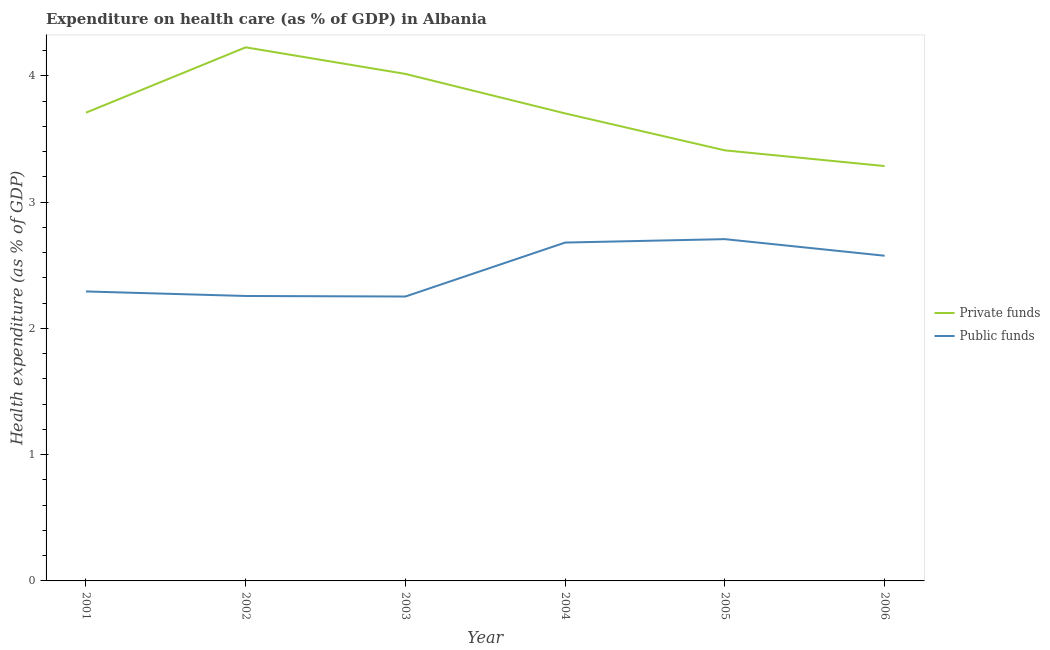How many different coloured lines are there?
Your answer should be very brief. 2. Does the line corresponding to amount of private funds spent in healthcare intersect with the line corresponding to amount of public funds spent in healthcare?
Make the answer very short. No. Is the number of lines equal to the number of legend labels?
Your answer should be very brief. Yes. What is the amount of public funds spent in healthcare in 2004?
Keep it short and to the point. 2.68. Across all years, what is the maximum amount of public funds spent in healthcare?
Give a very brief answer. 2.71. Across all years, what is the minimum amount of public funds spent in healthcare?
Offer a terse response. 2.25. In which year was the amount of public funds spent in healthcare maximum?
Ensure brevity in your answer.  2005. What is the total amount of private funds spent in healthcare in the graph?
Your answer should be very brief. 22.35. What is the difference between the amount of public funds spent in healthcare in 2001 and that in 2006?
Make the answer very short. -0.28. What is the difference between the amount of public funds spent in healthcare in 2004 and the amount of private funds spent in healthcare in 2002?
Your response must be concise. -1.55. What is the average amount of private funds spent in healthcare per year?
Provide a succinct answer. 3.72. In the year 2003, what is the difference between the amount of public funds spent in healthcare and amount of private funds spent in healthcare?
Your answer should be compact. -1.76. In how many years, is the amount of public funds spent in healthcare greater than 1.6 %?
Offer a very short reply. 6. What is the ratio of the amount of public funds spent in healthcare in 2001 to that in 2003?
Your response must be concise. 1.02. Is the amount of public funds spent in healthcare in 2001 less than that in 2003?
Keep it short and to the point. No. Is the difference between the amount of private funds spent in healthcare in 2004 and 2006 greater than the difference between the amount of public funds spent in healthcare in 2004 and 2006?
Ensure brevity in your answer.  Yes. What is the difference between the highest and the second highest amount of public funds spent in healthcare?
Your response must be concise. 0.03. What is the difference between the highest and the lowest amount of private funds spent in healthcare?
Keep it short and to the point. 0.94. Is the sum of the amount of public funds spent in healthcare in 2003 and 2004 greater than the maximum amount of private funds spent in healthcare across all years?
Ensure brevity in your answer.  Yes. Is the amount of private funds spent in healthcare strictly less than the amount of public funds spent in healthcare over the years?
Offer a very short reply. No. How many years are there in the graph?
Ensure brevity in your answer.  6. Where does the legend appear in the graph?
Your response must be concise. Center right. How are the legend labels stacked?
Offer a terse response. Vertical. What is the title of the graph?
Your answer should be very brief. Expenditure on health care (as % of GDP) in Albania. What is the label or title of the Y-axis?
Ensure brevity in your answer.  Health expenditure (as % of GDP). What is the Health expenditure (as % of GDP) of Private funds in 2001?
Your answer should be very brief. 3.71. What is the Health expenditure (as % of GDP) of Public funds in 2001?
Offer a terse response. 2.29. What is the Health expenditure (as % of GDP) of Private funds in 2002?
Provide a short and direct response. 4.23. What is the Health expenditure (as % of GDP) of Public funds in 2002?
Offer a very short reply. 2.26. What is the Health expenditure (as % of GDP) in Private funds in 2003?
Your answer should be compact. 4.01. What is the Health expenditure (as % of GDP) of Public funds in 2003?
Your answer should be compact. 2.25. What is the Health expenditure (as % of GDP) of Private funds in 2004?
Keep it short and to the point. 3.7. What is the Health expenditure (as % of GDP) in Public funds in 2004?
Offer a very short reply. 2.68. What is the Health expenditure (as % of GDP) of Private funds in 2005?
Your answer should be very brief. 3.41. What is the Health expenditure (as % of GDP) in Public funds in 2005?
Give a very brief answer. 2.71. What is the Health expenditure (as % of GDP) of Private funds in 2006?
Make the answer very short. 3.29. What is the Health expenditure (as % of GDP) in Public funds in 2006?
Keep it short and to the point. 2.58. Across all years, what is the maximum Health expenditure (as % of GDP) in Private funds?
Keep it short and to the point. 4.23. Across all years, what is the maximum Health expenditure (as % of GDP) in Public funds?
Your answer should be very brief. 2.71. Across all years, what is the minimum Health expenditure (as % of GDP) of Private funds?
Give a very brief answer. 3.29. Across all years, what is the minimum Health expenditure (as % of GDP) in Public funds?
Offer a very short reply. 2.25. What is the total Health expenditure (as % of GDP) of Private funds in the graph?
Offer a terse response. 22.35. What is the total Health expenditure (as % of GDP) of Public funds in the graph?
Offer a terse response. 14.76. What is the difference between the Health expenditure (as % of GDP) in Private funds in 2001 and that in 2002?
Keep it short and to the point. -0.52. What is the difference between the Health expenditure (as % of GDP) in Public funds in 2001 and that in 2002?
Ensure brevity in your answer.  0.04. What is the difference between the Health expenditure (as % of GDP) in Private funds in 2001 and that in 2003?
Give a very brief answer. -0.31. What is the difference between the Health expenditure (as % of GDP) of Public funds in 2001 and that in 2003?
Offer a terse response. 0.04. What is the difference between the Health expenditure (as % of GDP) of Private funds in 2001 and that in 2004?
Your response must be concise. 0.01. What is the difference between the Health expenditure (as % of GDP) of Public funds in 2001 and that in 2004?
Make the answer very short. -0.39. What is the difference between the Health expenditure (as % of GDP) of Private funds in 2001 and that in 2005?
Provide a short and direct response. 0.3. What is the difference between the Health expenditure (as % of GDP) in Public funds in 2001 and that in 2005?
Offer a very short reply. -0.41. What is the difference between the Health expenditure (as % of GDP) in Private funds in 2001 and that in 2006?
Your response must be concise. 0.42. What is the difference between the Health expenditure (as % of GDP) in Public funds in 2001 and that in 2006?
Give a very brief answer. -0.28. What is the difference between the Health expenditure (as % of GDP) of Private funds in 2002 and that in 2003?
Your answer should be very brief. 0.21. What is the difference between the Health expenditure (as % of GDP) of Public funds in 2002 and that in 2003?
Make the answer very short. 0. What is the difference between the Health expenditure (as % of GDP) of Private funds in 2002 and that in 2004?
Make the answer very short. 0.52. What is the difference between the Health expenditure (as % of GDP) of Public funds in 2002 and that in 2004?
Give a very brief answer. -0.42. What is the difference between the Health expenditure (as % of GDP) in Private funds in 2002 and that in 2005?
Your answer should be very brief. 0.82. What is the difference between the Health expenditure (as % of GDP) of Public funds in 2002 and that in 2005?
Your answer should be very brief. -0.45. What is the difference between the Health expenditure (as % of GDP) in Private funds in 2002 and that in 2006?
Give a very brief answer. 0.94. What is the difference between the Health expenditure (as % of GDP) in Public funds in 2002 and that in 2006?
Your answer should be compact. -0.32. What is the difference between the Health expenditure (as % of GDP) of Private funds in 2003 and that in 2004?
Make the answer very short. 0.31. What is the difference between the Health expenditure (as % of GDP) in Public funds in 2003 and that in 2004?
Keep it short and to the point. -0.43. What is the difference between the Health expenditure (as % of GDP) in Private funds in 2003 and that in 2005?
Provide a succinct answer. 0.61. What is the difference between the Health expenditure (as % of GDP) in Public funds in 2003 and that in 2005?
Ensure brevity in your answer.  -0.45. What is the difference between the Health expenditure (as % of GDP) of Private funds in 2003 and that in 2006?
Your answer should be very brief. 0.73. What is the difference between the Health expenditure (as % of GDP) of Public funds in 2003 and that in 2006?
Give a very brief answer. -0.32. What is the difference between the Health expenditure (as % of GDP) in Private funds in 2004 and that in 2005?
Your response must be concise. 0.29. What is the difference between the Health expenditure (as % of GDP) of Public funds in 2004 and that in 2005?
Your response must be concise. -0.03. What is the difference between the Health expenditure (as % of GDP) in Private funds in 2004 and that in 2006?
Give a very brief answer. 0.42. What is the difference between the Health expenditure (as % of GDP) in Public funds in 2004 and that in 2006?
Offer a terse response. 0.1. What is the difference between the Health expenditure (as % of GDP) of Private funds in 2005 and that in 2006?
Ensure brevity in your answer.  0.12. What is the difference between the Health expenditure (as % of GDP) in Public funds in 2005 and that in 2006?
Your answer should be compact. 0.13. What is the difference between the Health expenditure (as % of GDP) of Private funds in 2001 and the Health expenditure (as % of GDP) of Public funds in 2002?
Provide a short and direct response. 1.45. What is the difference between the Health expenditure (as % of GDP) of Private funds in 2001 and the Health expenditure (as % of GDP) of Public funds in 2003?
Keep it short and to the point. 1.46. What is the difference between the Health expenditure (as % of GDP) of Private funds in 2001 and the Health expenditure (as % of GDP) of Public funds in 2004?
Ensure brevity in your answer.  1.03. What is the difference between the Health expenditure (as % of GDP) in Private funds in 2001 and the Health expenditure (as % of GDP) in Public funds in 2006?
Keep it short and to the point. 1.13. What is the difference between the Health expenditure (as % of GDP) in Private funds in 2002 and the Health expenditure (as % of GDP) in Public funds in 2003?
Give a very brief answer. 1.97. What is the difference between the Health expenditure (as % of GDP) of Private funds in 2002 and the Health expenditure (as % of GDP) of Public funds in 2004?
Ensure brevity in your answer.  1.55. What is the difference between the Health expenditure (as % of GDP) of Private funds in 2002 and the Health expenditure (as % of GDP) of Public funds in 2005?
Your response must be concise. 1.52. What is the difference between the Health expenditure (as % of GDP) of Private funds in 2002 and the Health expenditure (as % of GDP) of Public funds in 2006?
Give a very brief answer. 1.65. What is the difference between the Health expenditure (as % of GDP) of Private funds in 2003 and the Health expenditure (as % of GDP) of Public funds in 2004?
Offer a terse response. 1.34. What is the difference between the Health expenditure (as % of GDP) of Private funds in 2003 and the Health expenditure (as % of GDP) of Public funds in 2005?
Provide a succinct answer. 1.31. What is the difference between the Health expenditure (as % of GDP) of Private funds in 2003 and the Health expenditure (as % of GDP) of Public funds in 2006?
Your answer should be very brief. 1.44. What is the difference between the Health expenditure (as % of GDP) of Private funds in 2004 and the Health expenditure (as % of GDP) of Public funds in 2005?
Offer a terse response. 1. What is the difference between the Health expenditure (as % of GDP) in Private funds in 2004 and the Health expenditure (as % of GDP) in Public funds in 2006?
Your response must be concise. 1.13. What is the difference between the Health expenditure (as % of GDP) of Private funds in 2005 and the Health expenditure (as % of GDP) of Public funds in 2006?
Your response must be concise. 0.83. What is the average Health expenditure (as % of GDP) in Private funds per year?
Provide a short and direct response. 3.72. What is the average Health expenditure (as % of GDP) of Public funds per year?
Offer a terse response. 2.46. In the year 2001, what is the difference between the Health expenditure (as % of GDP) of Private funds and Health expenditure (as % of GDP) of Public funds?
Your response must be concise. 1.42. In the year 2002, what is the difference between the Health expenditure (as % of GDP) in Private funds and Health expenditure (as % of GDP) in Public funds?
Make the answer very short. 1.97. In the year 2003, what is the difference between the Health expenditure (as % of GDP) in Private funds and Health expenditure (as % of GDP) in Public funds?
Offer a terse response. 1.76. In the year 2004, what is the difference between the Health expenditure (as % of GDP) in Private funds and Health expenditure (as % of GDP) in Public funds?
Offer a very short reply. 1.02. In the year 2005, what is the difference between the Health expenditure (as % of GDP) in Private funds and Health expenditure (as % of GDP) in Public funds?
Offer a terse response. 0.7. In the year 2006, what is the difference between the Health expenditure (as % of GDP) in Private funds and Health expenditure (as % of GDP) in Public funds?
Ensure brevity in your answer.  0.71. What is the ratio of the Health expenditure (as % of GDP) in Private funds in 2001 to that in 2002?
Offer a terse response. 0.88. What is the ratio of the Health expenditure (as % of GDP) of Public funds in 2001 to that in 2002?
Ensure brevity in your answer.  1.02. What is the ratio of the Health expenditure (as % of GDP) in Private funds in 2001 to that in 2003?
Keep it short and to the point. 0.92. What is the ratio of the Health expenditure (as % of GDP) in Public funds in 2001 to that in 2003?
Offer a terse response. 1.02. What is the ratio of the Health expenditure (as % of GDP) of Private funds in 2001 to that in 2004?
Make the answer very short. 1. What is the ratio of the Health expenditure (as % of GDP) of Public funds in 2001 to that in 2004?
Keep it short and to the point. 0.86. What is the ratio of the Health expenditure (as % of GDP) in Private funds in 2001 to that in 2005?
Provide a short and direct response. 1.09. What is the ratio of the Health expenditure (as % of GDP) of Public funds in 2001 to that in 2005?
Ensure brevity in your answer.  0.85. What is the ratio of the Health expenditure (as % of GDP) in Private funds in 2001 to that in 2006?
Provide a short and direct response. 1.13. What is the ratio of the Health expenditure (as % of GDP) in Public funds in 2001 to that in 2006?
Offer a very short reply. 0.89. What is the ratio of the Health expenditure (as % of GDP) in Private funds in 2002 to that in 2003?
Offer a very short reply. 1.05. What is the ratio of the Health expenditure (as % of GDP) of Private funds in 2002 to that in 2004?
Provide a short and direct response. 1.14. What is the ratio of the Health expenditure (as % of GDP) in Public funds in 2002 to that in 2004?
Provide a short and direct response. 0.84. What is the ratio of the Health expenditure (as % of GDP) in Private funds in 2002 to that in 2005?
Provide a short and direct response. 1.24. What is the ratio of the Health expenditure (as % of GDP) in Public funds in 2002 to that in 2005?
Your response must be concise. 0.83. What is the ratio of the Health expenditure (as % of GDP) in Private funds in 2002 to that in 2006?
Offer a very short reply. 1.29. What is the ratio of the Health expenditure (as % of GDP) in Public funds in 2002 to that in 2006?
Keep it short and to the point. 0.88. What is the ratio of the Health expenditure (as % of GDP) of Private funds in 2003 to that in 2004?
Offer a terse response. 1.08. What is the ratio of the Health expenditure (as % of GDP) in Public funds in 2003 to that in 2004?
Your answer should be compact. 0.84. What is the ratio of the Health expenditure (as % of GDP) of Private funds in 2003 to that in 2005?
Make the answer very short. 1.18. What is the ratio of the Health expenditure (as % of GDP) in Public funds in 2003 to that in 2005?
Offer a very short reply. 0.83. What is the ratio of the Health expenditure (as % of GDP) in Private funds in 2003 to that in 2006?
Provide a short and direct response. 1.22. What is the ratio of the Health expenditure (as % of GDP) of Public funds in 2003 to that in 2006?
Make the answer very short. 0.87. What is the ratio of the Health expenditure (as % of GDP) of Private funds in 2004 to that in 2005?
Provide a succinct answer. 1.09. What is the ratio of the Health expenditure (as % of GDP) in Public funds in 2004 to that in 2005?
Your answer should be very brief. 0.99. What is the ratio of the Health expenditure (as % of GDP) in Private funds in 2004 to that in 2006?
Provide a succinct answer. 1.13. What is the ratio of the Health expenditure (as % of GDP) of Public funds in 2004 to that in 2006?
Your answer should be very brief. 1.04. What is the ratio of the Health expenditure (as % of GDP) of Private funds in 2005 to that in 2006?
Your answer should be compact. 1.04. What is the ratio of the Health expenditure (as % of GDP) in Public funds in 2005 to that in 2006?
Provide a short and direct response. 1.05. What is the difference between the highest and the second highest Health expenditure (as % of GDP) in Private funds?
Offer a very short reply. 0.21. What is the difference between the highest and the second highest Health expenditure (as % of GDP) of Public funds?
Keep it short and to the point. 0.03. What is the difference between the highest and the lowest Health expenditure (as % of GDP) in Private funds?
Offer a terse response. 0.94. What is the difference between the highest and the lowest Health expenditure (as % of GDP) of Public funds?
Keep it short and to the point. 0.45. 